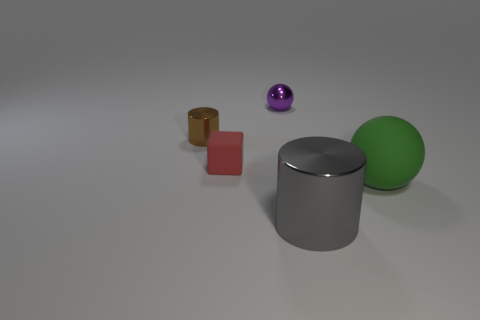What is the size of the purple metal object that is the same shape as the large rubber object?
Your response must be concise. Small. There is a thing that is both to the right of the small brown shiny object and behind the red thing; what material is it made of?
Give a very brief answer. Metal. Is the size of the green sphere the same as the ball that is behind the red object?
Make the answer very short. No. What number of other things are there of the same color as the tiny sphere?
Make the answer very short. 0. Is the number of tiny red cubes right of the brown metallic thing greater than the number of gray rubber balls?
Provide a succinct answer. Yes. There is a tiny shiny object that is left of the tiny metal thing right of the tiny shiny thing in front of the tiny purple object; what color is it?
Provide a succinct answer. Brown. Are the purple object and the large cylinder made of the same material?
Offer a very short reply. Yes. Is there another purple rubber ball of the same size as the matte ball?
Your answer should be very brief. No. There is a purple object that is the same size as the brown cylinder; what is it made of?
Keep it short and to the point. Metal. Is there a tiny red rubber thing that has the same shape as the large matte thing?
Keep it short and to the point. No. 